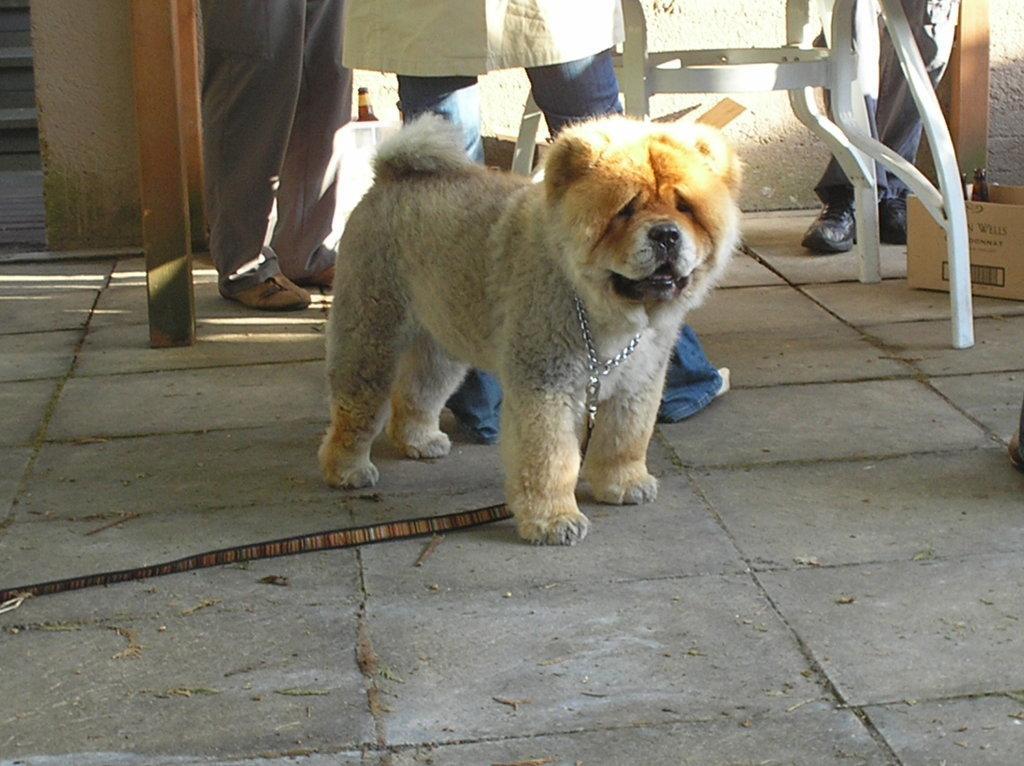Can you describe this image briefly? In the image there is a puppy standing on floor and behind there are few people standing around table. 